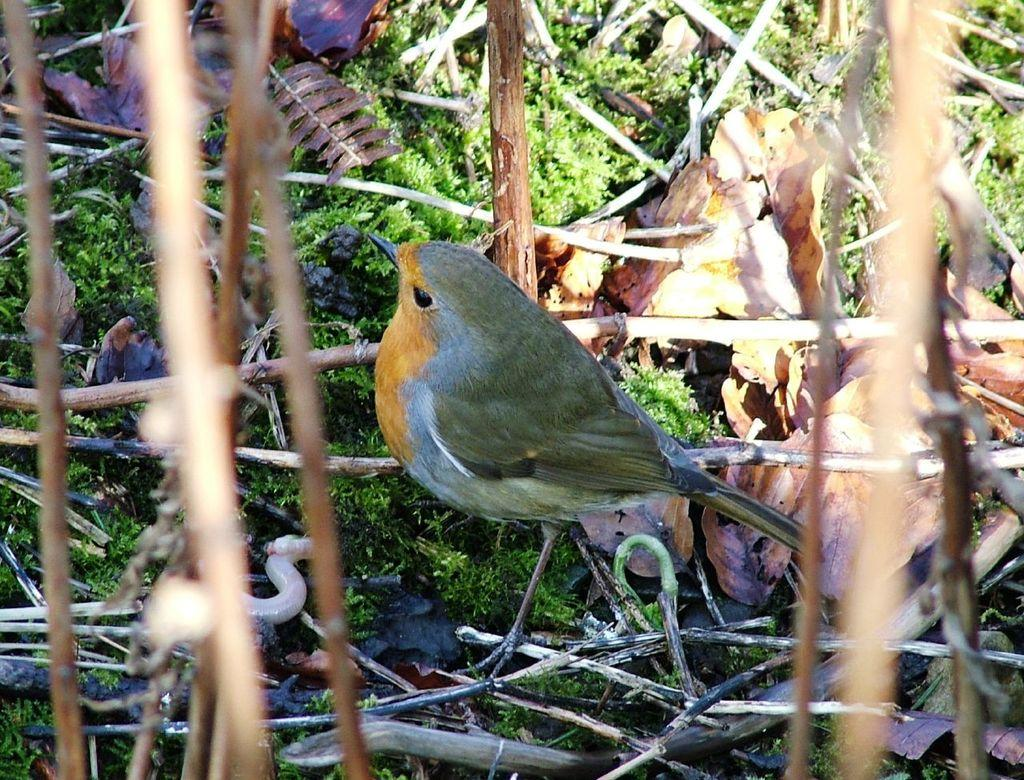What is the main subject in the center of the image? There is a bird in the center of the image. What type of material can be seen in the image? There are wooden sticks and dry leaves present in the image. What is the condition of the ground in the image? Grass is visible at the bottom of the image. What else can be found in the image? There is scrap in the image. How does the bird's uncle communicate with it in the image? There is no uncle present in the image, and therefore no communication between the bird and an uncle can be observed. 